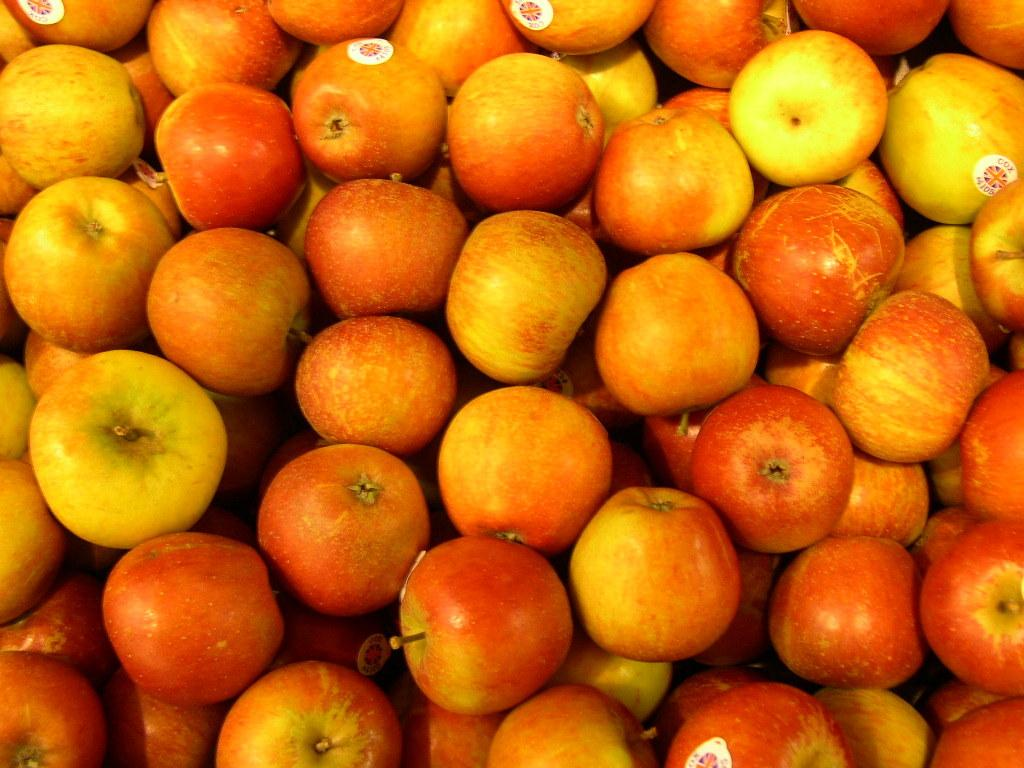What type of fruit is present in the image? There are many apples in the image. Are the apples in the image marked or labeled in any way? Yes, there are stickers on the apples. What does the pan need to cook the apples in the image? There is no pan present in the image, so it cannot be determined what it might need to cook the apples. 